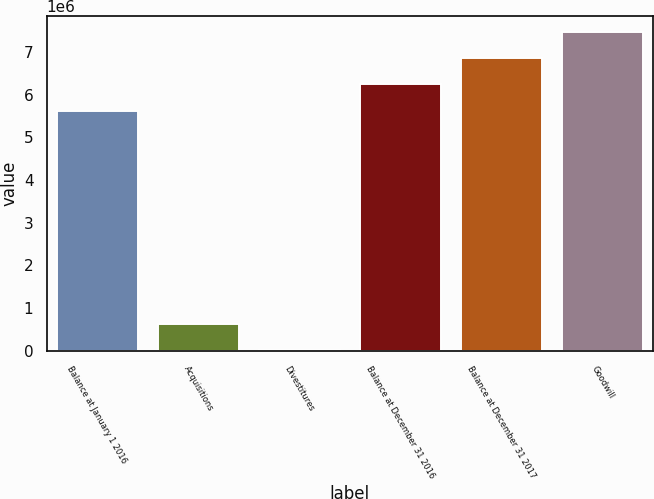<chart> <loc_0><loc_0><loc_500><loc_500><bar_chart><fcel>Balance at January 1 2016<fcel>Acquisitions<fcel>Divestitures<fcel>Balance at December 31 2016<fcel>Balance at December 31 2017<fcel>Goodwill<nl><fcel>5.62918e+06<fcel>626078<fcel>12891<fcel>6.24237e+06<fcel>6.85556e+06<fcel>7.46874e+06<nl></chart> 